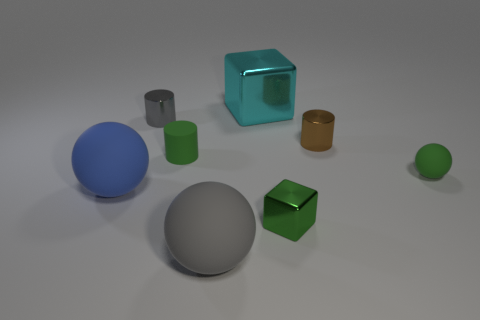Are there any other things that have the same material as the gray sphere?
Make the answer very short. Yes. There is a large thing that is right of the blue matte sphere and in front of the cyan object; what is its material?
Offer a very short reply. Rubber. What number of small brown metal objects are the same shape as the small gray thing?
Make the answer very short. 1. What is the color of the metal object that is left of the gray object that is in front of the brown cylinder?
Provide a succinct answer. Gray. Are there the same number of rubber spheres that are on the left side of the tiny green rubber cylinder and metal objects?
Offer a terse response. No. Is there a gray rubber thing that has the same size as the blue matte ball?
Keep it short and to the point. Yes. Is the size of the brown cylinder the same as the matte thing in front of the small green metal thing?
Offer a very short reply. No. Are there the same number of big objects in front of the tiny green cylinder and metal things left of the large shiny block?
Offer a very short reply. No. The tiny rubber object that is the same color as the matte cylinder is what shape?
Your answer should be very brief. Sphere. There is a cube that is in front of the tiny gray shiny cylinder; what is it made of?
Ensure brevity in your answer.  Metal. 